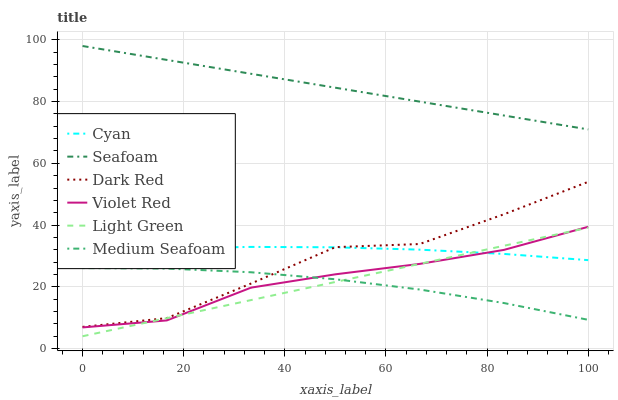Does Dark Red have the minimum area under the curve?
Answer yes or no. No. Does Dark Red have the maximum area under the curve?
Answer yes or no. No. Is Seafoam the smoothest?
Answer yes or no. No. Is Seafoam the roughest?
Answer yes or no. No. Does Dark Red have the lowest value?
Answer yes or no. No. Does Dark Red have the highest value?
Answer yes or no. No. Is Light Green less than Dark Red?
Answer yes or no. Yes. Is Cyan greater than Medium Seafoam?
Answer yes or no. Yes. Does Light Green intersect Dark Red?
Answer yes or no. No. 